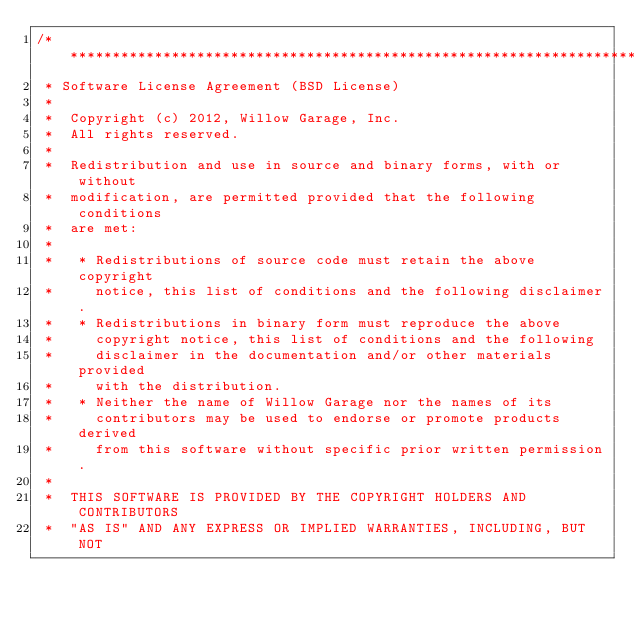Convert code to text. <code><loc_0><loc_0><loc_500><loc_500><_C++_>/*********************************************************************
 * Software License Agreement (BSD License)
 *
 *  Copyright (c) 2012, Willow Garage, Inc.
 *  All rights reserved.
 *
 *  Redistribution and use in source and binary forms, with or without
 *  modification, are permitted provided that the following conditions
 *  are met:
 *
 *   * Redistributions of source code must retain the above copyright
 *     notice, this list of conditions and the following disclaimer.
 *   * Redistributions in binary form must reproduce the above
 *     copyright notice, this list of conditions and the following
 *     disclaimer in the documentation and/or other materials provided
 *     with the distribution.
 *   * Neither the name of Willow Garage nor the names of its
 *     contributors may be used to endorse or promote products derived
 *     from this software without specific prior written permission.
 *
 *  THIS SOFTWARE IS PROVIDED BY THE COPYRIGHT HOLDERS AND CONTRIBUTORS
 *  "AS IS" AND ANY EXPRESS OR IMPLIED WARRANTIES, INCLUDING, BUT NOT</code> 